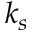<formula> <loc_0><loc_0><loc_500><loc_500>k _ { s }</formula> 